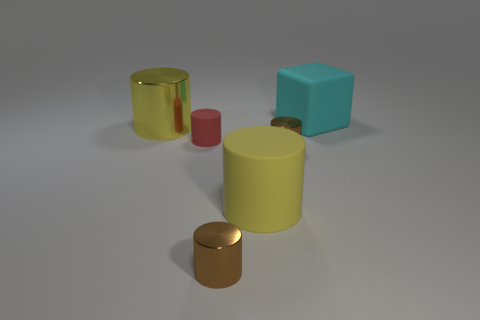Are any small blue matte cubes visible?
Offer a very short reply. No. What color is the big object that is both to the right of the big shiny thing and to the left of the large cyan thing?
Your answer should be very brief. Yellow. Do the rubber thing that is behind the tiny matte thing and the yellow cylinder that is in front of the red rubber object have the same size?
Offer a very short reply. Yes. There is a rubber cylinder behind the big yellow matte object; what number of big cubes are left of it?
Keep it short and to the point. 0. Are there fewer small rubber things behind the large block than green rubber objects?
Provide a succinct answer. No. There is a large matte thing in front of the cyan rubber object that is behind the object that is to the left of the red thing; what is its shape?
Your answer should be very brief. Cylinder. Does the big yellow metallic object have the same shape as the big cyan rubber object?
Your answer should be compact. No. What number of other things are the same shape as the small red thing?
Your response must be concise. 4. What is the color of the metal object that is the same size as the block?
Keep it short and to the point. Yellow. Is the number of brown shiny objects that are behind the large yellow shiny object the same as the number of tiny yellow cylinders?
Your answer should be compact. Yes. 